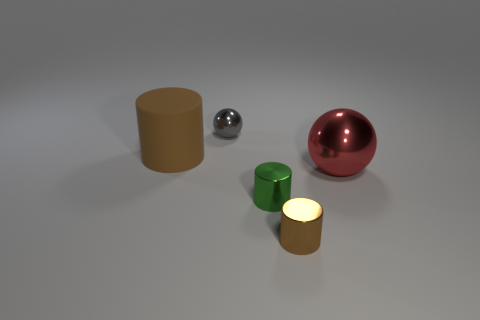There is a brown object that is in front of the big object that is left of the large red metal thing; what size is it?
Offer a very short reply. Small. Does the small object that is behind the big red ball have the same material as the small green thing?
Ensure brevity in your answer.  Yes. What is the shape of the small object behind the large red shiny sphere?
Your answer should be very brief. Sphere. How many brown cylinders have the same size as the green shiny object?
Keep it short and to the point. 1. How big is the red object?
Keep it short and to the point. Large. What number of rubber cylinders are behind the big metal sphere?
Make the answer very short. 1. There is a tiny green object that is the same material as the small sphere; what is its shape?
Your answer should be compact. Cylinder. Are there fewer gray shiny spheres in front of the tiny brown metallic cylinder than brown matte cylinders behind the red metallic ball?
Keep it short and to the point. Yes. Are there more tiny metal cylinders than large red metal cylinders?
Provide a short and direct response. Yes. What is the gray object made of?
Your response must be concise. Metal. 